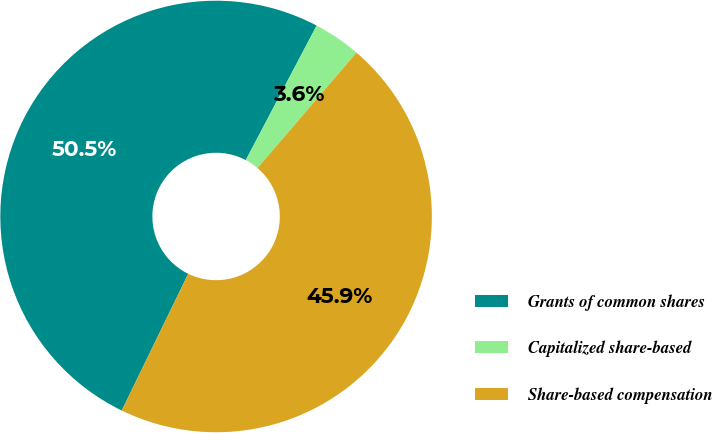<chart> <loc_0><loc_0><loc_500><loc_500><pie_chart><fcel>Grants of common shares<fcel>Capitalized share-based<fcel>Share-based compensation<nl><fcel>50.52%<fcel>3.56%<fcel>45.93%<nl></chart> 